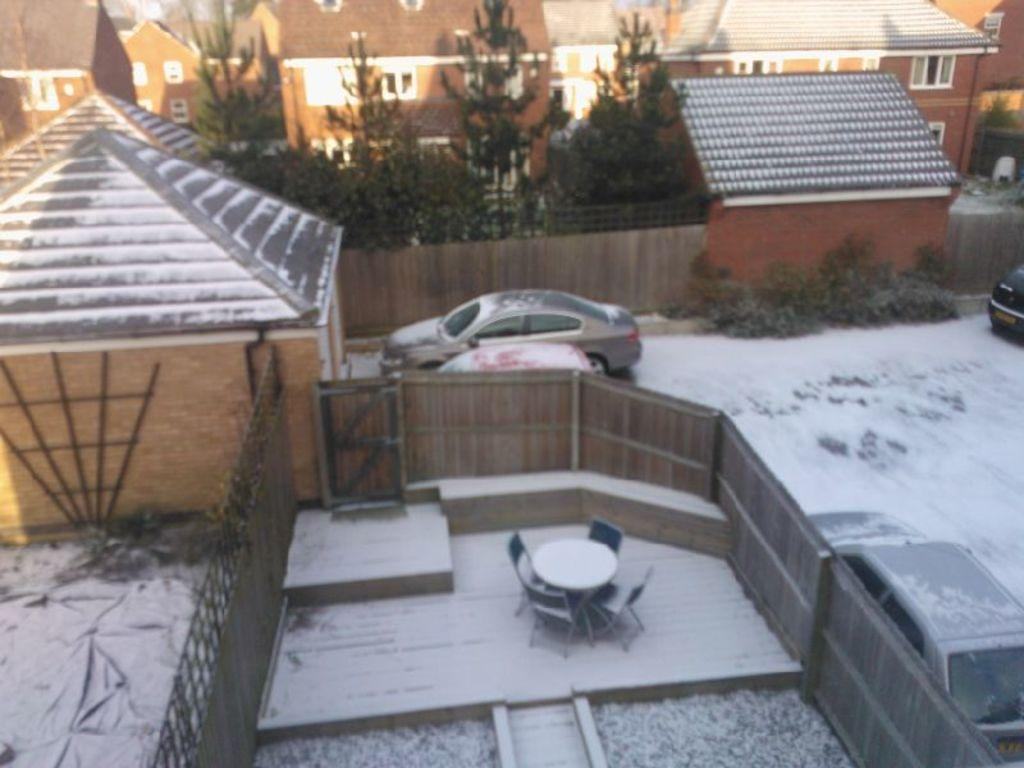What type of structures can be seen in the image? There are houses in the image. What vehicles are present in the image? There are cars in the image. What type of fencing is visible in the image? There is wooden fencing in the image. What covers most of the area in the image? Most of the area is covered with ice. What type of vegetation is around the houses? There are trees around the houses. Can you see the moon in the image? The moon is not visible in the image; it is focused on houses, cars, wooden fencing, ice, and trees. What type of screw is used to hold the wooden fencing together in the image? There is no mention of screws in the image; it only describes wooden fencing. 